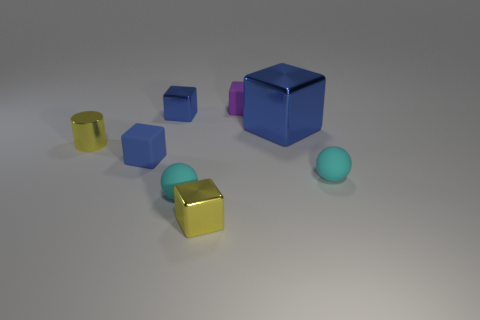How many other things are there of the same shape as the large object?
Provide a short and direct response. 4. What number of objects are tiny blue shiny things that are behind the big metal thing or blocks that are to the left of the big cube?
Make the answer very short. 4. What size is the block that is both behind the large blue block and on the left side of the purple rubber block?
Provide a succinct answer. Small. Does the yellow object to the right of the tiny cylinder have the same shape as the purple rubber thing?
Offer a very short reply. Yes. How big is the yellow thing that is in front of the blue rubber cube in front of the big thing on the right side of the small yellow metallic cylinder?
Ensure brevity in your answer.  Small. There is a cube that is the same color as the tiny cylinder; what is its size?
Offer a terse response. Small. How many things are small cyan things or small rubber cubes?
Your answer should be very brief. 4. The tiny object that is to the right of the yellow block and in front of the yellow cylinder has what shape?
Make the answer very short. Sphere. There is a large blue metallic thing; is its shape the same as the small matte object behind the tiny metallic cylinder?
Your answer should be compact. Yes. There is a purple cube; are there any big blue objects in front of it?
Provide a short and direct response. Yes. 